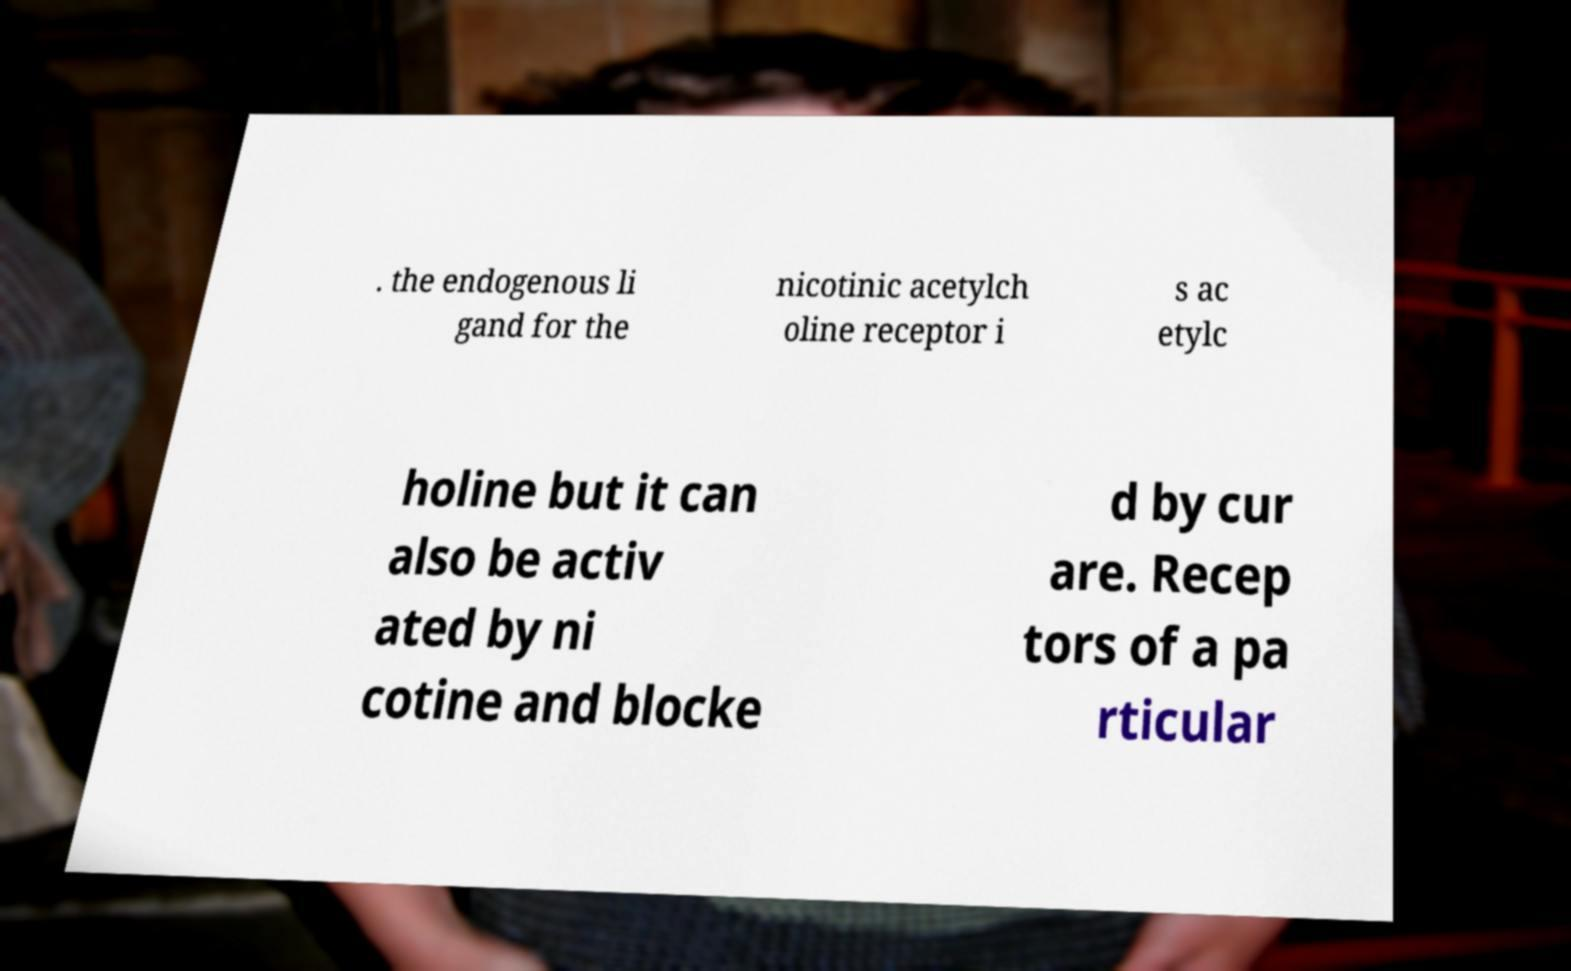What messages or text are displayed in this image? I need them in a readable, typed format. . the endogenous li gand for the nicotinic acetylch oline receptor i s ac etylc holine but it can also be activ ated by ni cotine and blocke d by cur are. Recep tors of a pa rticular 